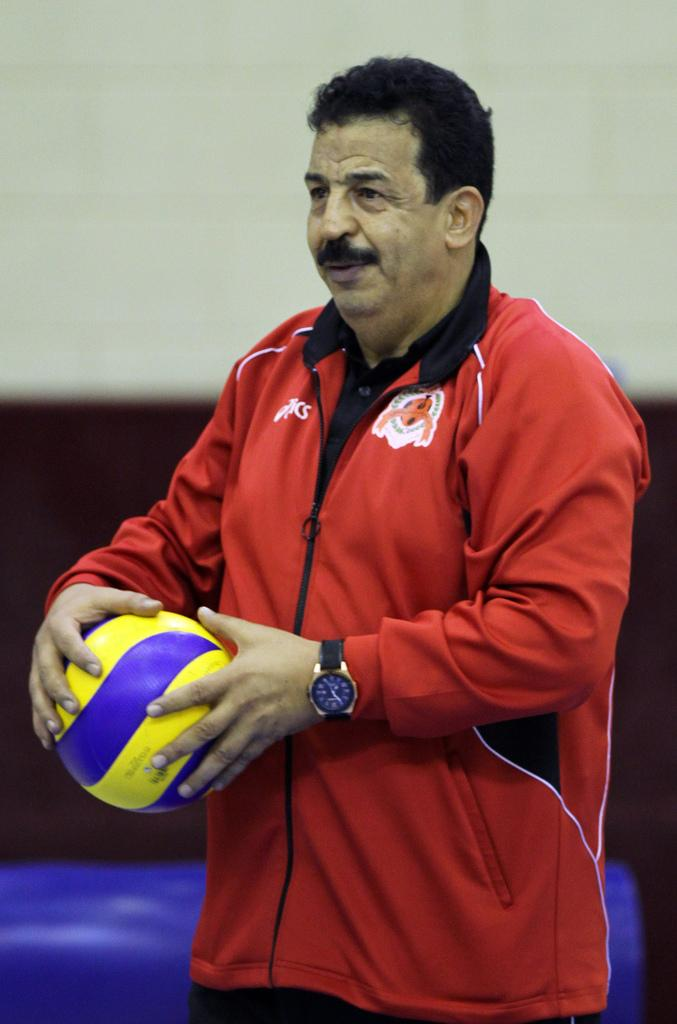What is the person in the image doing? The person is standing. What color is the jacket the person is wearing? The person is wearing a red color jacket. What object is the person holding? The person is holding a ball. What accessory is the person wearing on their wrist? The person is wearing a watch. What type of monkey can be seen wearing the person's underwear in the image? There is no monkey or underwear present in the image. 